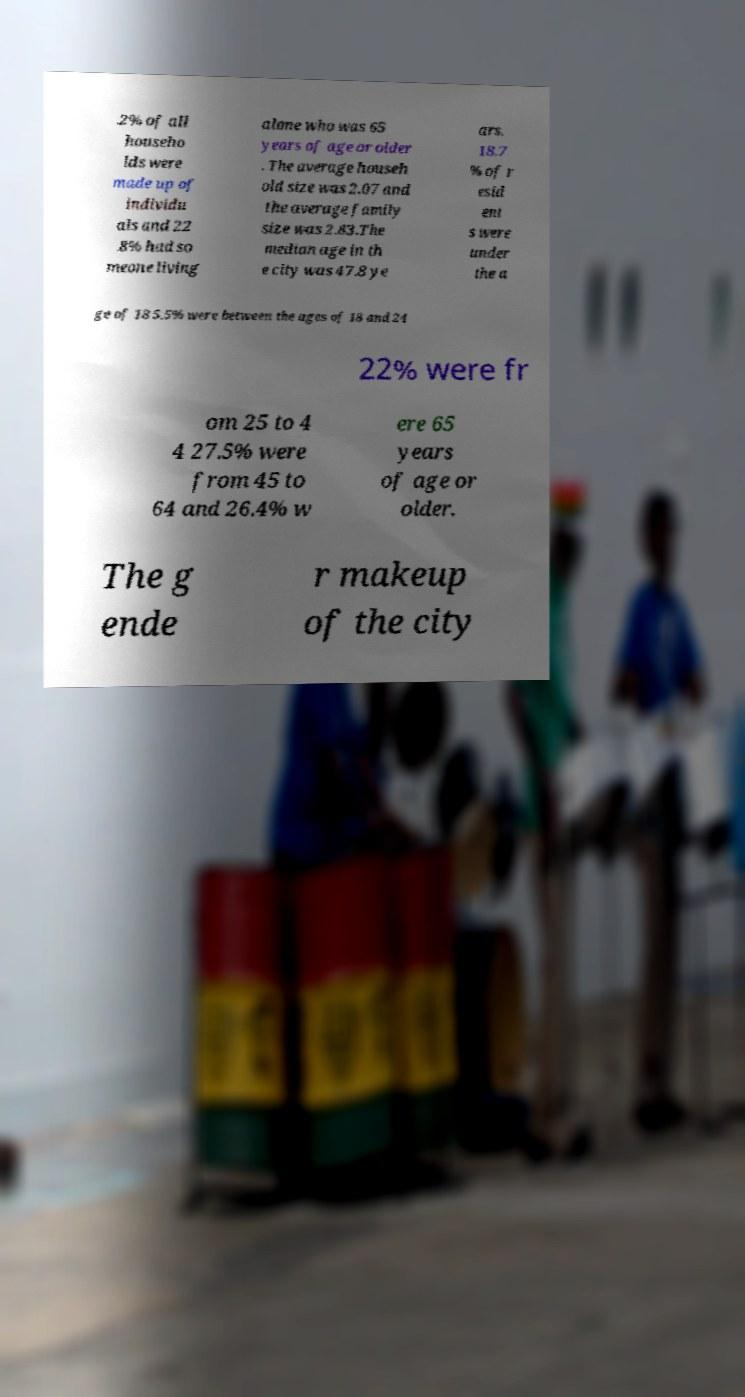Can you accurately transcribe the text from the provided image for me? .2% of all househo lds were made up of individu als and 22 .8% had so meone living alone who was 65 years of age or older . The average househ old size was 2.07 and the average family size was 2.83.The median age in th e city was 47.8 ye ars. 18.7 % of r esid ent s were under the a ge of 18 5.5% were between the ages of 18 and 24 22% were fr om 25 to 4 4 27.5% were from 45 to 64 and 26.4% w ere 65 years of age or older. The g ende r makeup of the city 